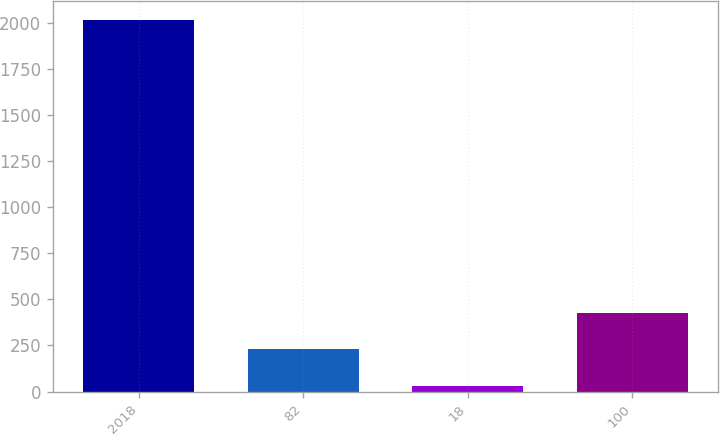Convert chart. <chart><loc_0><loc_0><loc_500><loc_500><bar_chart><fcel>2018<fcel>82<fcel>18<fcel>100<nl><fcel>2017<fcel>228.7<fcel>30<fcel>427.4<nl></chart> 